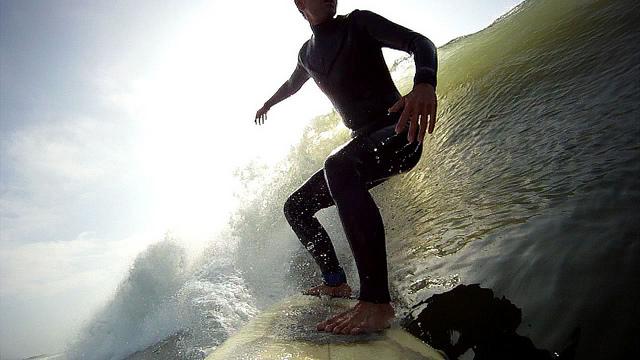What color is the surfboard?
Quick response, please. White. What color is his wetsuit?
Answer briefly. Black. Is the man surfing?
Quick response, please. Yes. 